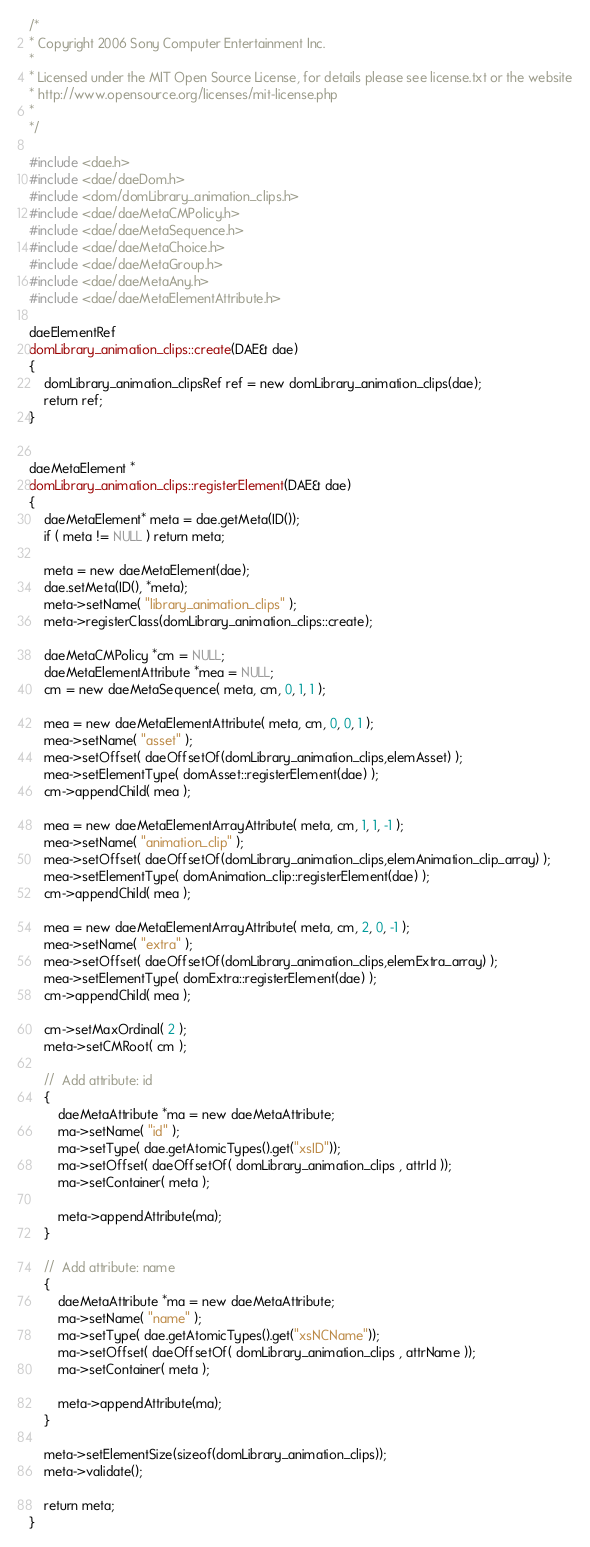Convert code to text. <code><loc_0><loc_0><loc_500><loc_500><_C++_>/*
* Copyright 2006 Sony Computer Entertainment Inc.
*
* Licensed under the MIT Open Source License, for details please see license.txt or the website
* http://www.opensource.org/licenses/mit-license.php
*
*/ 

#include <dae.h>
#include <dae/daeDom.h>
#include <dom/domLibrary_animation_clips.h>
#include <dae/daeMetaCMPolicy.h>
#include <dae/daeMetaSequence.h>
#include <dae/daeMetaChoice.h>
#include <dae/daeMetaGroup.h>
#include <dae/daeMetaAny.h>
#include <dae/daeMetaElementAttribute.h>

daeElementRef
domLibrary_animation_clips::create(DAE& dae)
{
	domLibrary_animation_clipsRef ref = new domLibrary_animation_clips(dae);
	return ref;
}


daeMetaElement *
domLibrary_animation_clips::registerElement(DAE& dae)
{
	daeMetaElement* meta = dae.getMeta(ID());
	if ( meta != NULL ) return meta;

	meta = new daeMetaElement(dae);
	dae.setMeta(ID(), *meta);
	meta->setName( "library_animation_clips" );
	meta->registerClass(domLibrary_animation_clips::create);

	daeMetaCMPolicy *cm = NULL;
	daeMetaElementAttribute *mea = NULL;
	cm = new daeMetaSequence( meta, cm, 0, 1, 1 );

	mea = new daeMetaElementAttribute( meta, cm, 0, 0, 1 );
	mea->setName( "asset" );
	mea->setOffset( daeOffsetOf(domLibrary_animation_clips,elemAsset) );
	mea->setElementType( domAsset::registerElement(dae) );
	cm->appendChild( mea );

	mea = new daeMetaElementArrayAttribute( meta, cm, 1, 1, -1 );
	mea->setName( "animation_clip" );
	mea->setOffset( daeOffsetOf(domLibrary_animation_clips,elemAnimation_clip_array) );
	mea->setElementType( domAnimation_clip::registerElement(dae) );
	cm->appendChild( mea );

	mea = new daeMetaElementArrayAttribute( meta, cm, 2, 0, -1 );
	mea->setName( "extra" );
	mea->setOffset( daeOffsetOf(domLibrary_animation_clips,elemExtra_array) );
	mea->setElementType( domExtra::registerElement(dae) );
	cm->appendChild( mea );

	cm->setMaxOrdinal( 2 );
	meta->setCMRoot( cm );	

	//	Add attribute: id
	{
		daeMetaAttribute *ma = new daeMetaAttribute;
		ma->setName( "id" );
		ma->setType( dae.getAtomicTypes().get("xsID"));
		ma->setOffset( daeOffsetOf( domLibrary_animation_clips , attrId ));
		ma->setContainer( meta );
	
		meta->appendAttribute(ma);
	}

	//	Add attribute: name
	{
		daeMetaAttribute *ma = new daeMetaAttribute;
		ma->setName( "name" );
		ma->setType( dae.getAtomicTypes().get("xsNCName"));
		ma->setOffset( daeOffsetOf( domLibrary_animation_clips , attrName ));
		ma->setContainer( meta );
	
		meta->appendAttribute(ma);
	}

	meta->setElementSize(sizeof(domLibrary_animation_clips));
	meta->validate();

	return meta;
}

</code> 